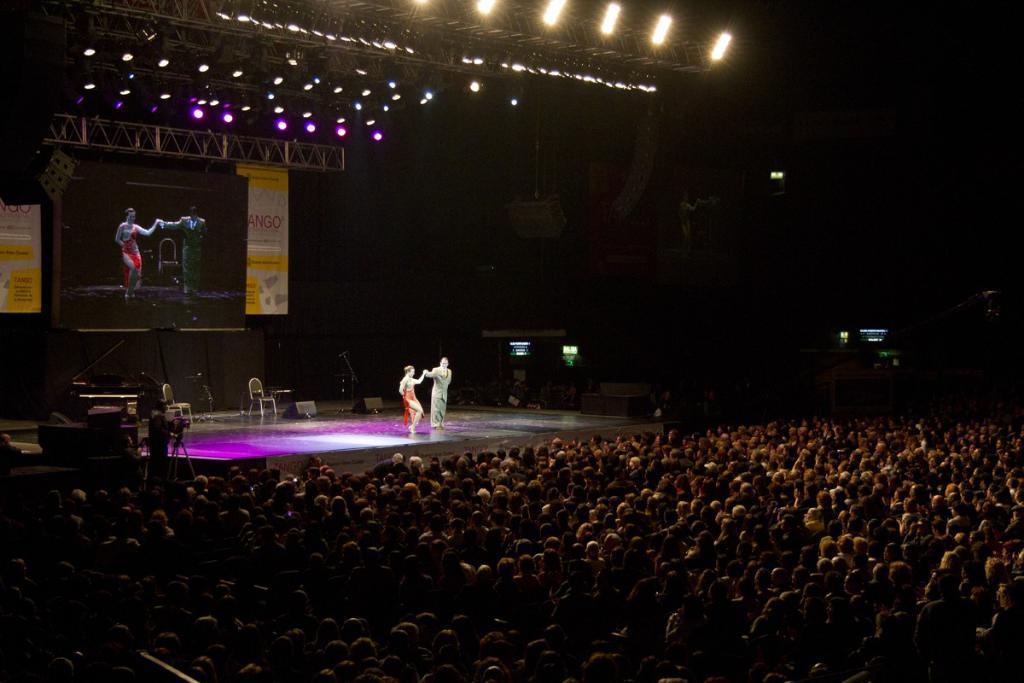In one or two sentences, can you explain what this image depicts? In this picture we can see a group of people sitting on chairs and in front of them we can see two people standing, chairs and some objects on stage and in the background we can see a screen, banners, lights and some objects and it is dark. 